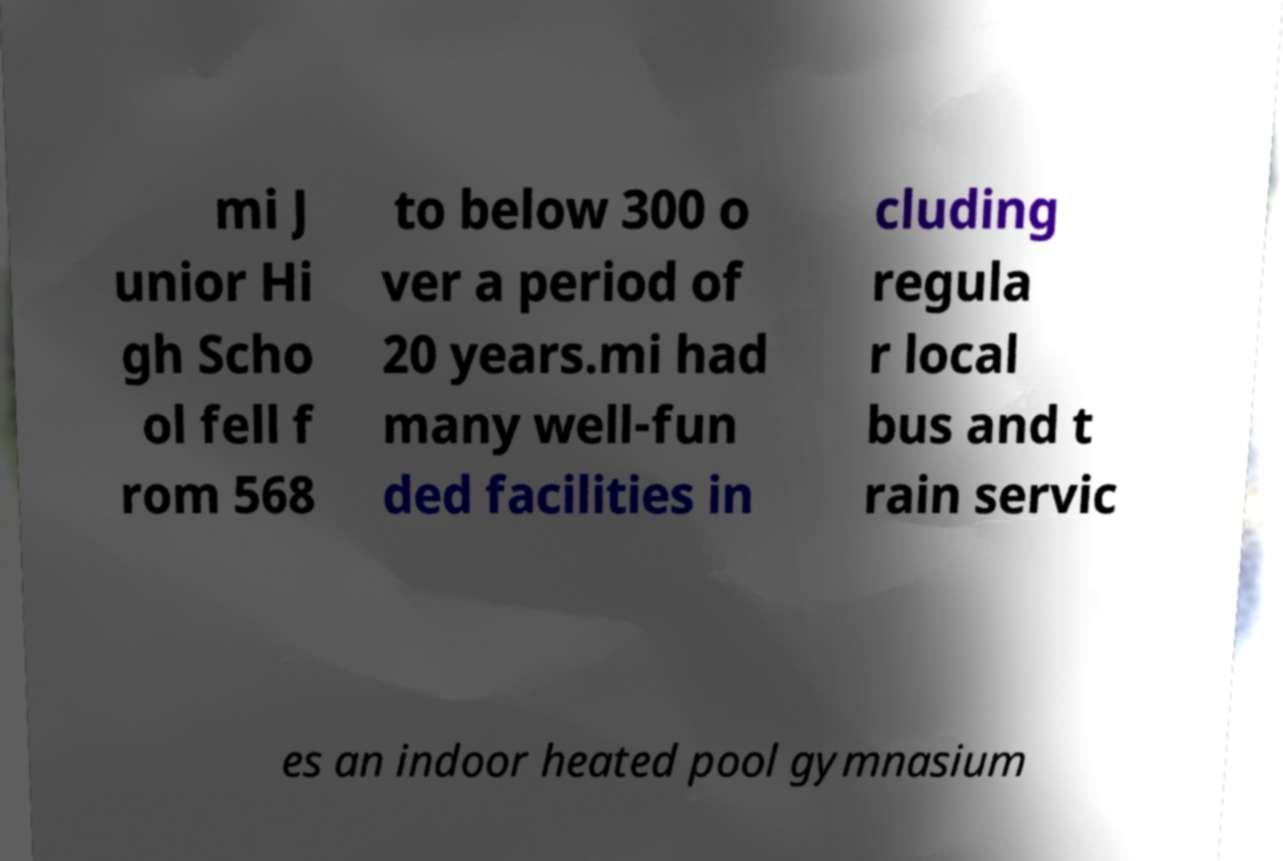For documentation purposes, I need the text within this image transcribed. Could you provide that? mi J unior Hi gh Scho ol fell f rom 568 to below 300 o ver a period of 20 years.mi had many well-fun ded facilities in cluding regula r local bus and t rain servic es an indoor heated pool gymnasium 